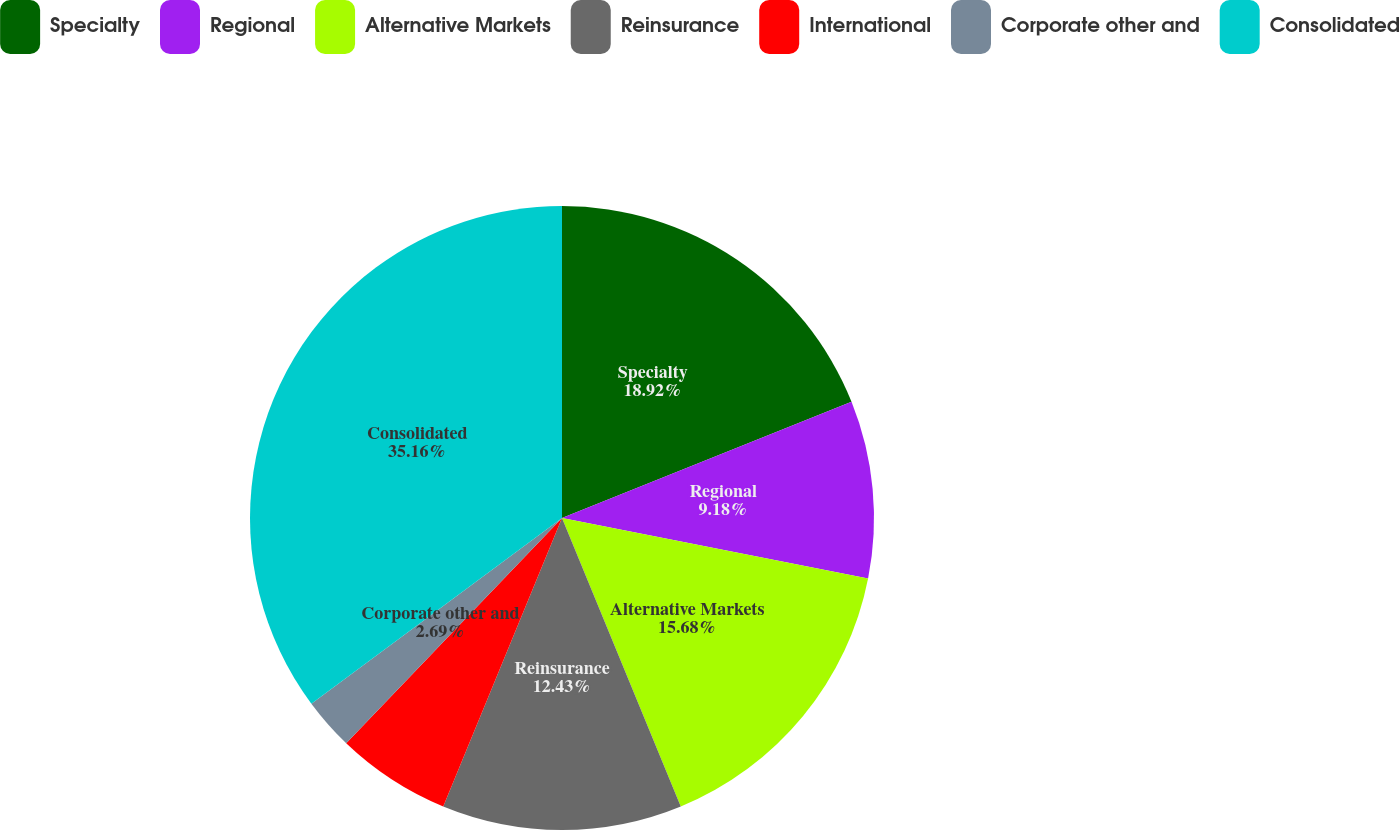Convert chart. <chart><loc_0><loc_0><loc_500><loc_500><pie_chart><fcel>Specialty<fcel>Regional<fcel>Alternative Markets<fcel>Reinsurance<fcel>International<fcel>Corporate other and<fcel>Consolidated<nl><fcel>18.92%<fcel>9.18%<fcel>15.68%<fcel>12.43%<fcel>5.94%<fcel>2.69%<fcel>35.15%<nl></chart> 